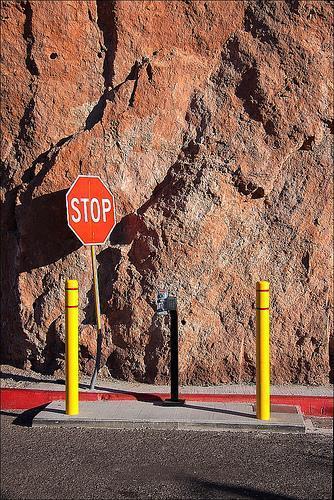How many stop signs can you see?
Give a very brief answer. 1. 